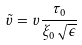<formula> <loc_0><loc_0><loc_500><loc_500>\tilde { v } = v \frac { \tau _ { 0 } } { \xi _ { 0 } \sqrt { \epsilon } }</formula> 